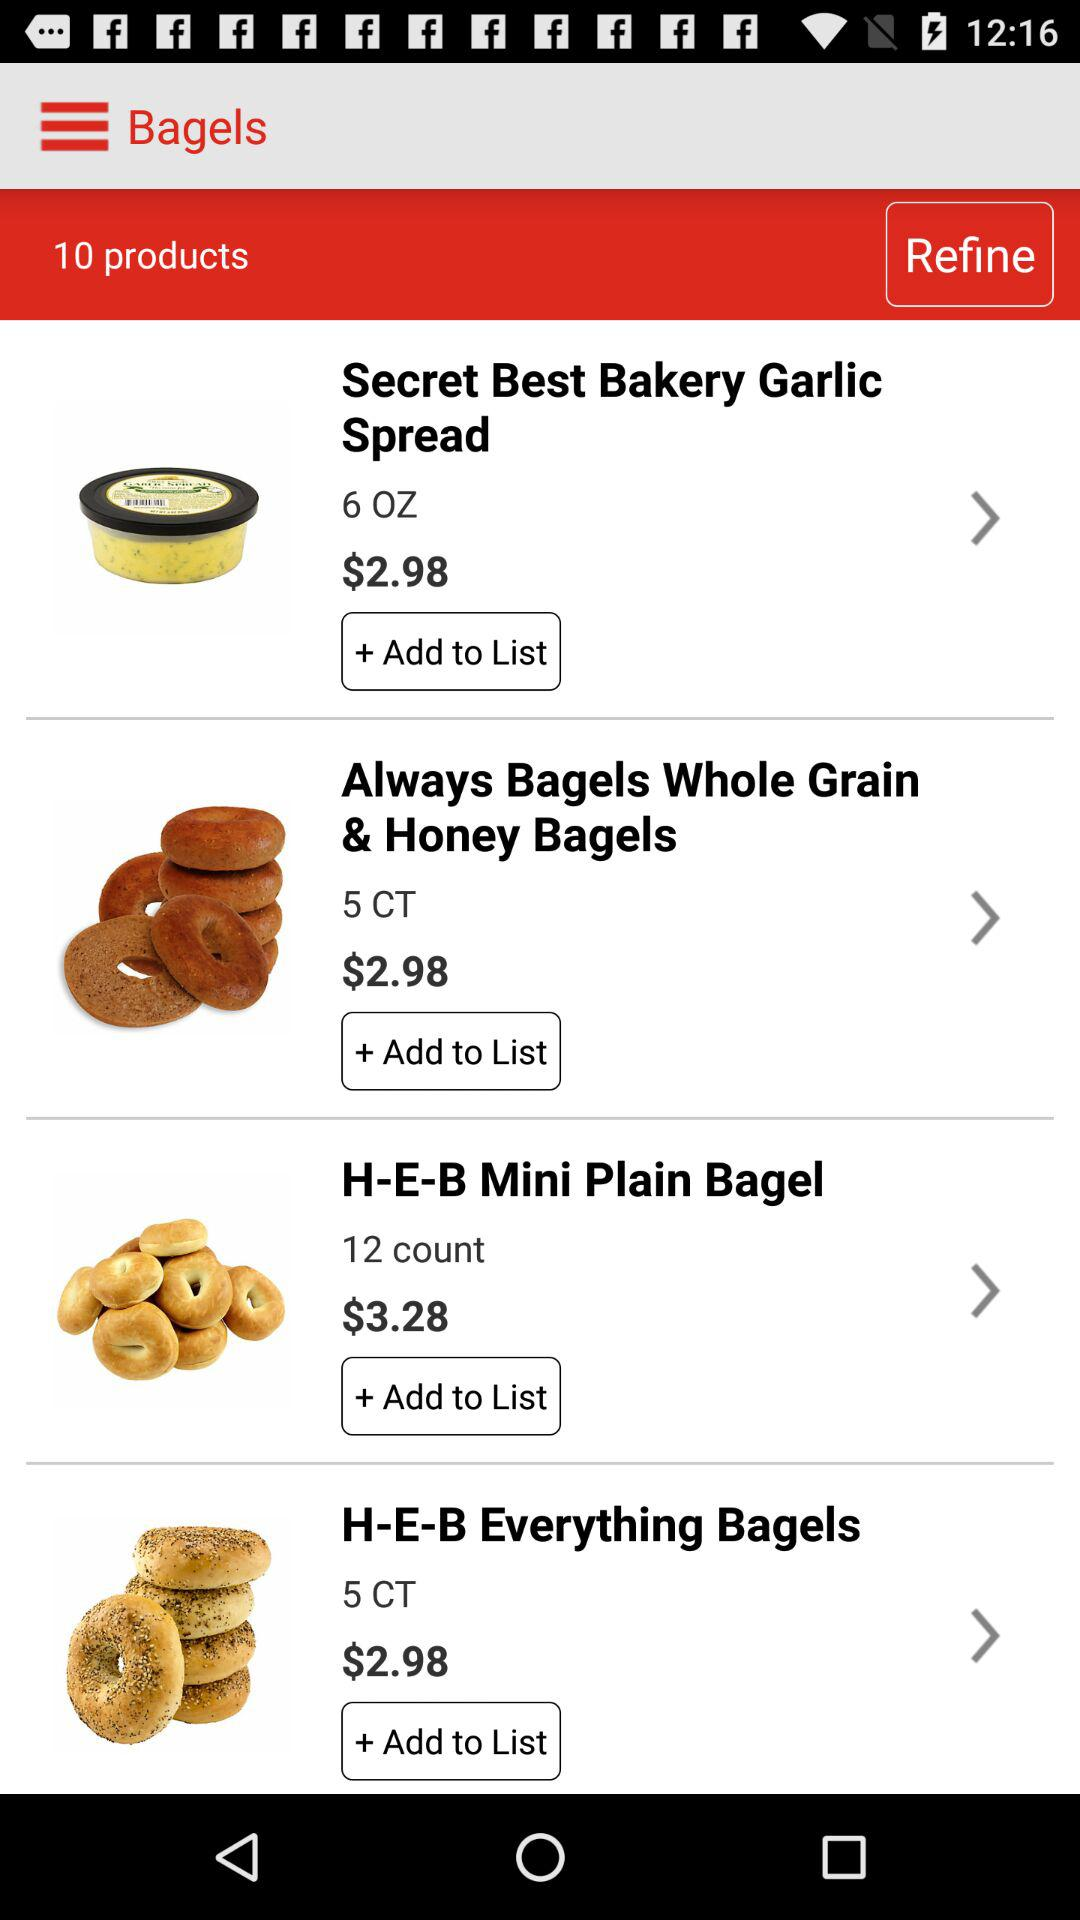How many items are priced at $3.28?
Answer the question using a single word or phrase. 1 